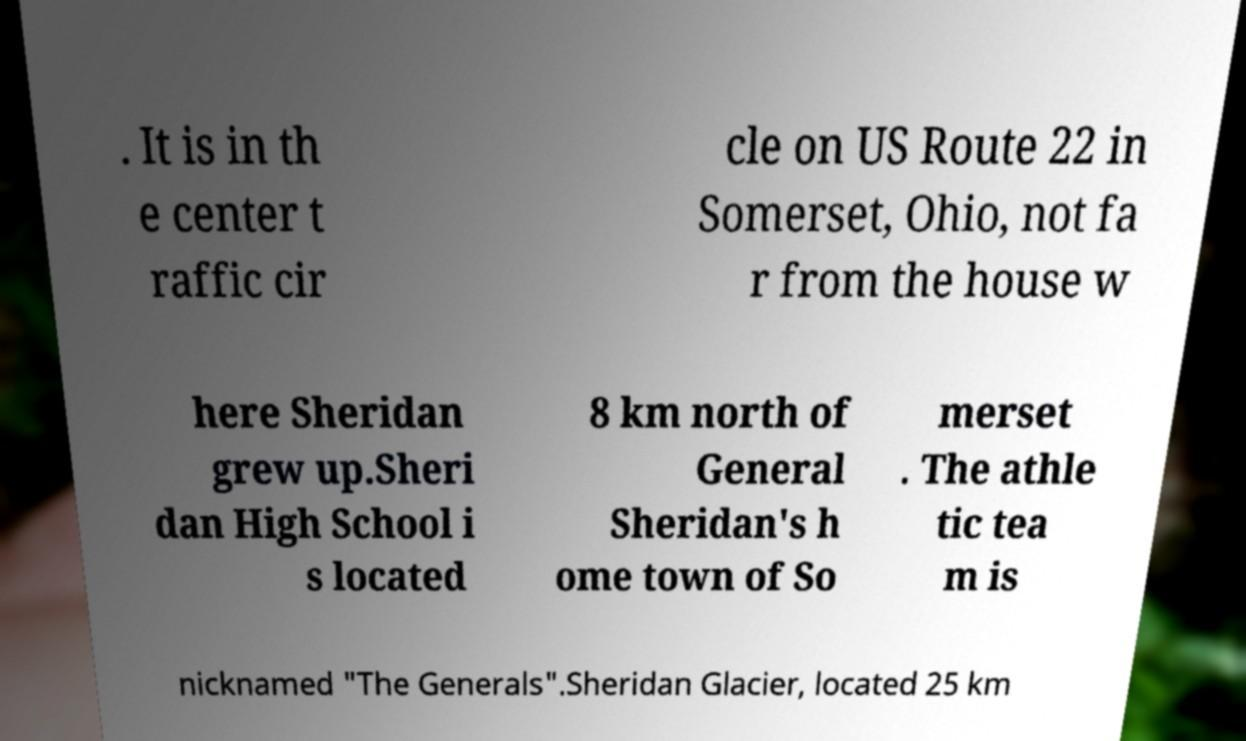Can you read and provide the text displayed in the image?This photo seems to have some interesting text. Can you extract and type it out for me? . It is in th e center t raffic cir cle on US Route 22 in Somerset, Ohio, not fa r from the house w here Sheridan grew up.Sheri dan High School i s located 8 km north of General Sheridan's h ome town of So merset . The athle tic tea m is nicknamed "The Generals".Sheridan Glacier, located 25 km 